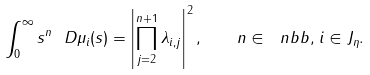<formula> <loc_0><loc_0><loc_500><loc_500>\int _ { 0 } ^ { \infty } s ^ { n } \ D \mu _ { i } ( s ) = \left | \prod _ { j = 2 } ^ { n + 1 } \lambda _ { i , j } \right | ^ { 2 } , \quad n \in \ n b b , \, i \in J _ { \eta } .</formula> 